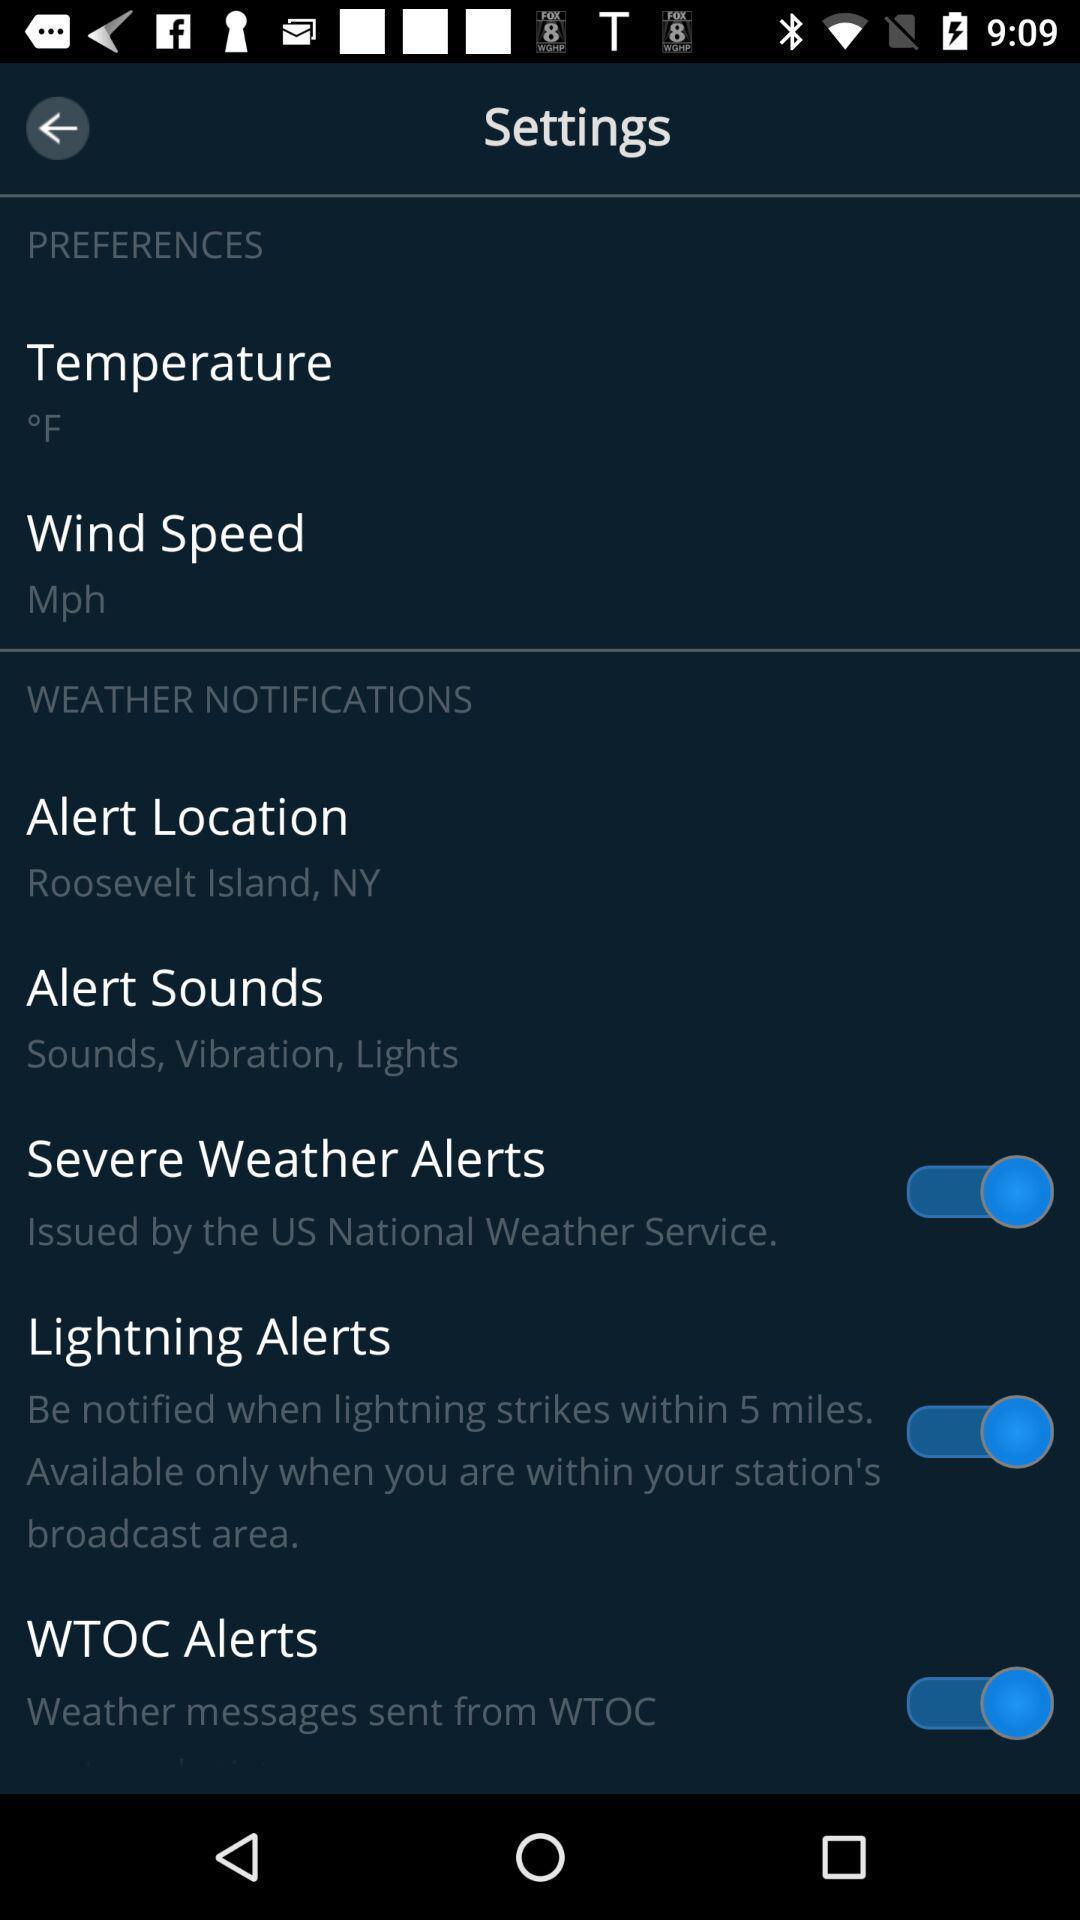Give me a summary of this screen capture. Screen showing settings page. 